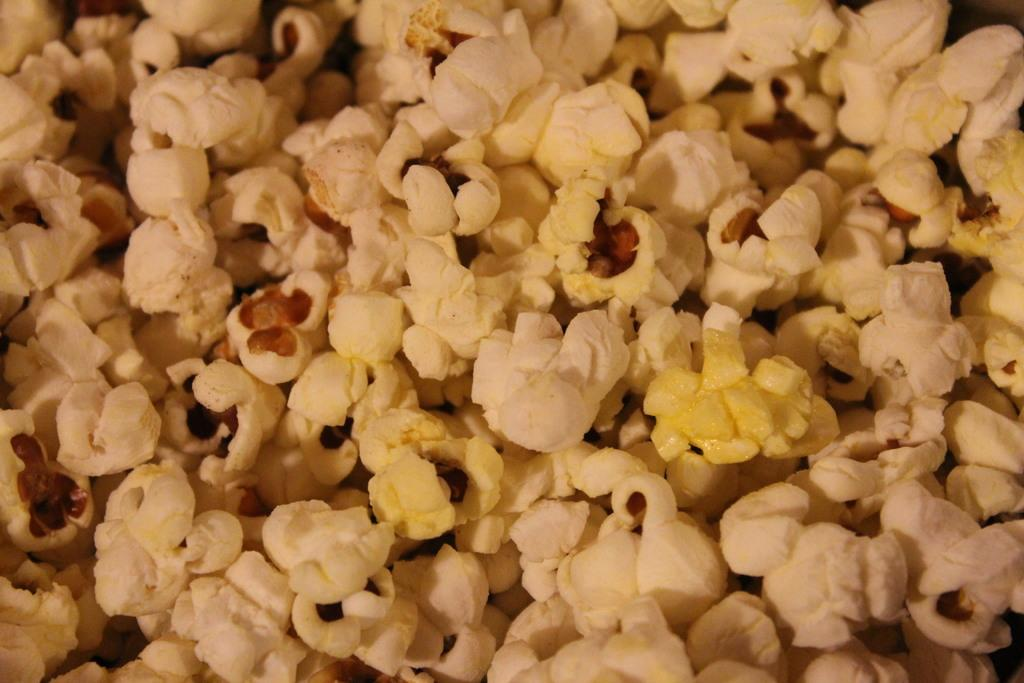What type of food is visible on the surface in the image? There is popcorn on the surface in the image. What decision did the popcorn make in the image? Popcorn cannot make decisions, as it is an inanimate object. 